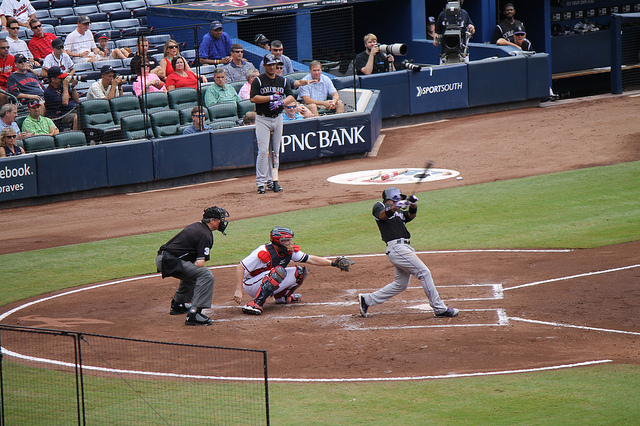Who is an all-time legend for one of these teams?
A. michael jordan
B. leroy garrett
C. todd helton
D. tom brady
Answer with the option's letter from the given choices directly. The all-time legend for one of the teams pictured, which could be inferred as a baseball team based on the image's context of a baseball game, would not be Todd Helton as he is a legend for the Colorado Rockies. Given the options, none are directly associated with the team shown in the image, as Michael Jordan is a basketball legend, Leroy Garrett is not prominently known in the context of sports legends, and Tom Brady is a football legend. The question does not provide the correct answer for the legend of the team depicted, which in the context of a baseball game could be someone from the Atlanta Braves or a related team seen playing. Moving forward, an accurate response would require the inclusion of a well-known figure associated with the specific team featured in the image. 